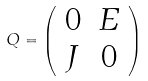Convert formula to latex. <formula><loc_0><loc_0><loc_500><loc_500>Q = \left ( \begin{array} { c c } 0 & E \\ J & 0 \end{array} \right )</formula> 